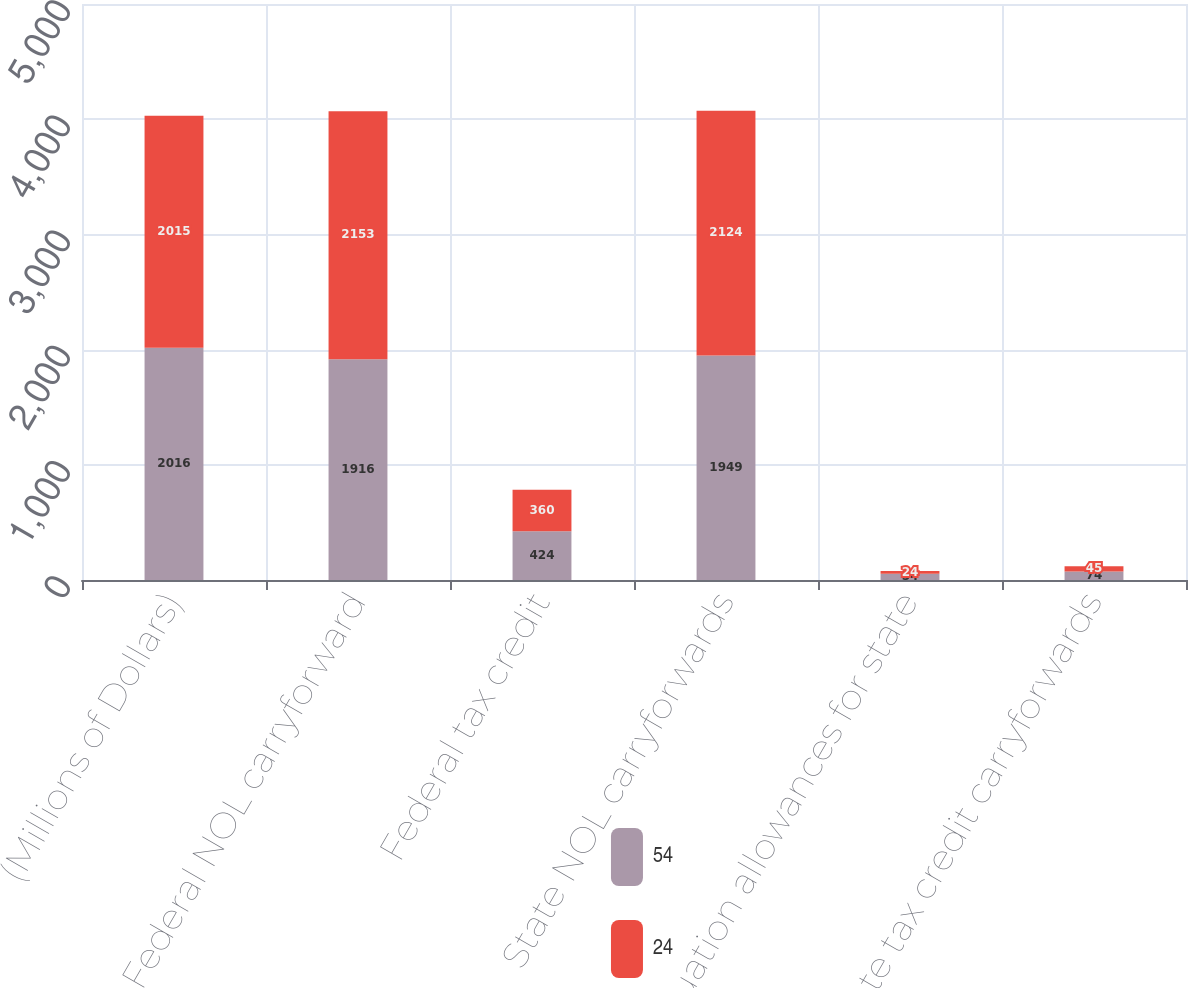Convert chart to OTSL. <chart><loc_0><loc_0><loc_500><loc_500><stacked_bar_chart><ecel><fcel>(Millions of Dollars)<fcel>Federal NOL carryforward<fcel>Federal tax credit<fcel>State NOL carryforwards<fcel>Valuation allowances for state<fcel>State tax credit carryforwards<nl><fcel>54<fcel>2016<fcel>1916<fcel>424<fcel>1949<fcel>54<fcel>74<nl><fcel>24<fcel>2015<fcel>2153<fcel>360<fcel>2124<fcel>24<fcel>45<nl></chart> 